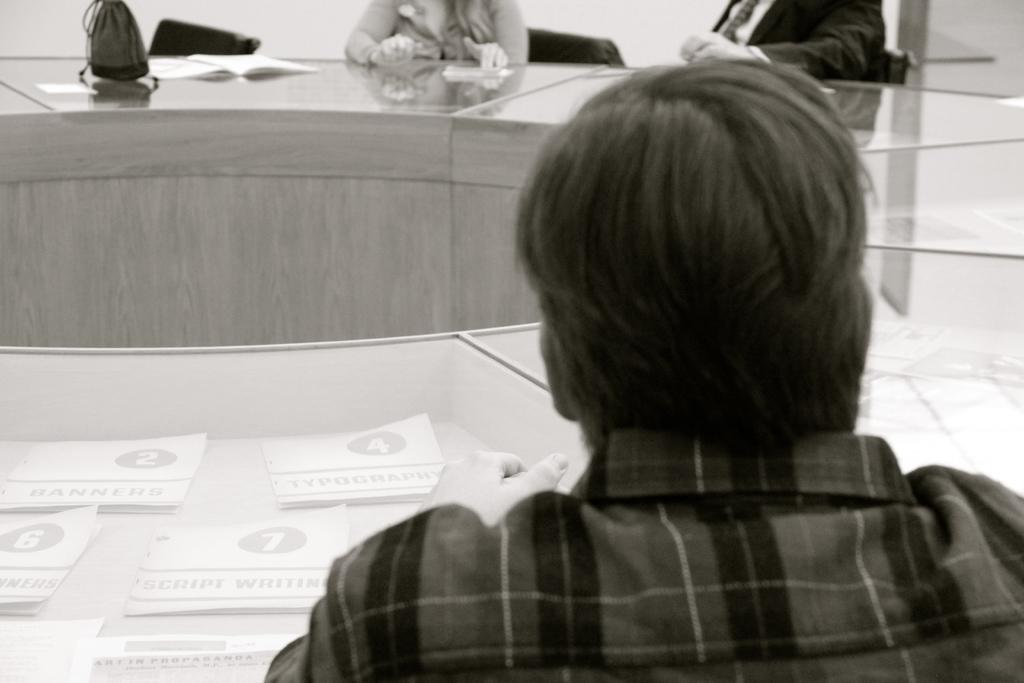How many people are in the image? There are three people in the image. What are the people doing in the image? The people are sitting on chairs. What is located in front of the chairs? There is a table in front of the chairs. What items can be seen on the table? There are papers, a book, and a bag on the table. What can be seen in the background of the image? There is a wall in the background. What is the color of the wall? The wall is white in color. What type of locket can be seen hanging from the wall in the image? There is no locket present on the wall in the image. Can you describe the stream that is visible in the background of the image? There is no stream visible in the background of the image; it features a white wall. 